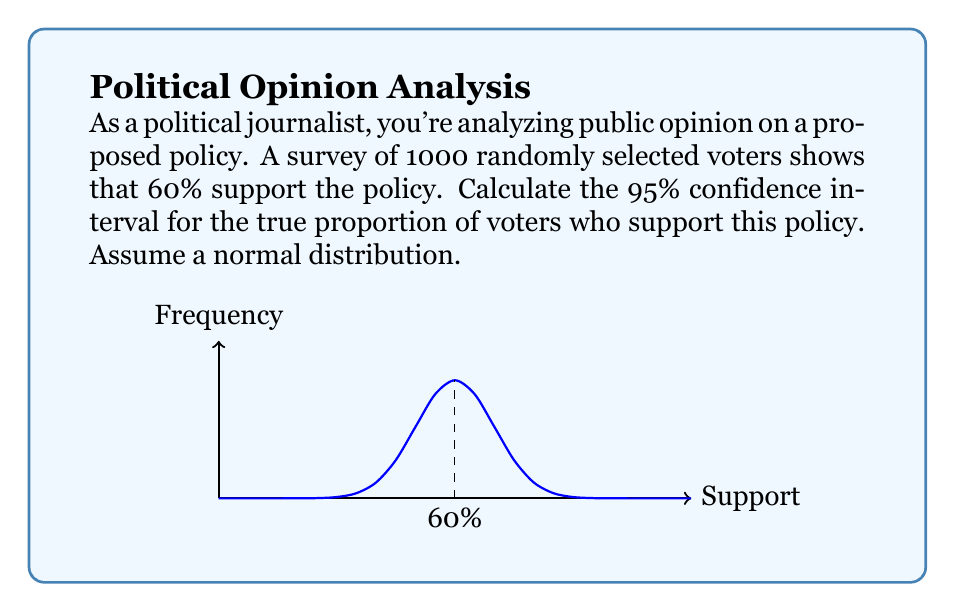Can you solve this math problem? Let's approach this step-by-step:

1) First, we need to identify our variables:
   $n$ = sample size = 1000
   $\hat{p}$ = sample proportion = 0.60
   Confidence level = 95% (z-score = 1.96)

2) The formula for the confidence interval is:

   $$\hat{p} \pm z \sqrt{\frac{\hat{p}(1-\hat{p})}{n}}$$

3) Let's calculate the standard error:

   $$SE = \sqrt{\frac{\hat{p}(1-\hat{p})}{n}} = \sqrt{\frac{0.60(1-0.60)}{1000}} = \sqrt{\frac{0.24}{1000}} = 0.0155$$

4) Now, let's calculate the margin of error:

   $$ME = z \times SE = 1.96 \times 0.0155 = 0.0304$$

5) Finally, we can calculate the confidence interval:

   Lower bound: $0.60 - 0.0304 = 0.5696$
   Upper bound: $0.60 + 0.0304 = 0.6304$

6) We typically round to 3 decimal places for reporting:

   Confidence Interval: (0.570, 0.630)

This means we can be 95% confident that the true proportion of voters who support the policy is between 57.0% and 63.0%.
Answer: (0.570, 0.630) 